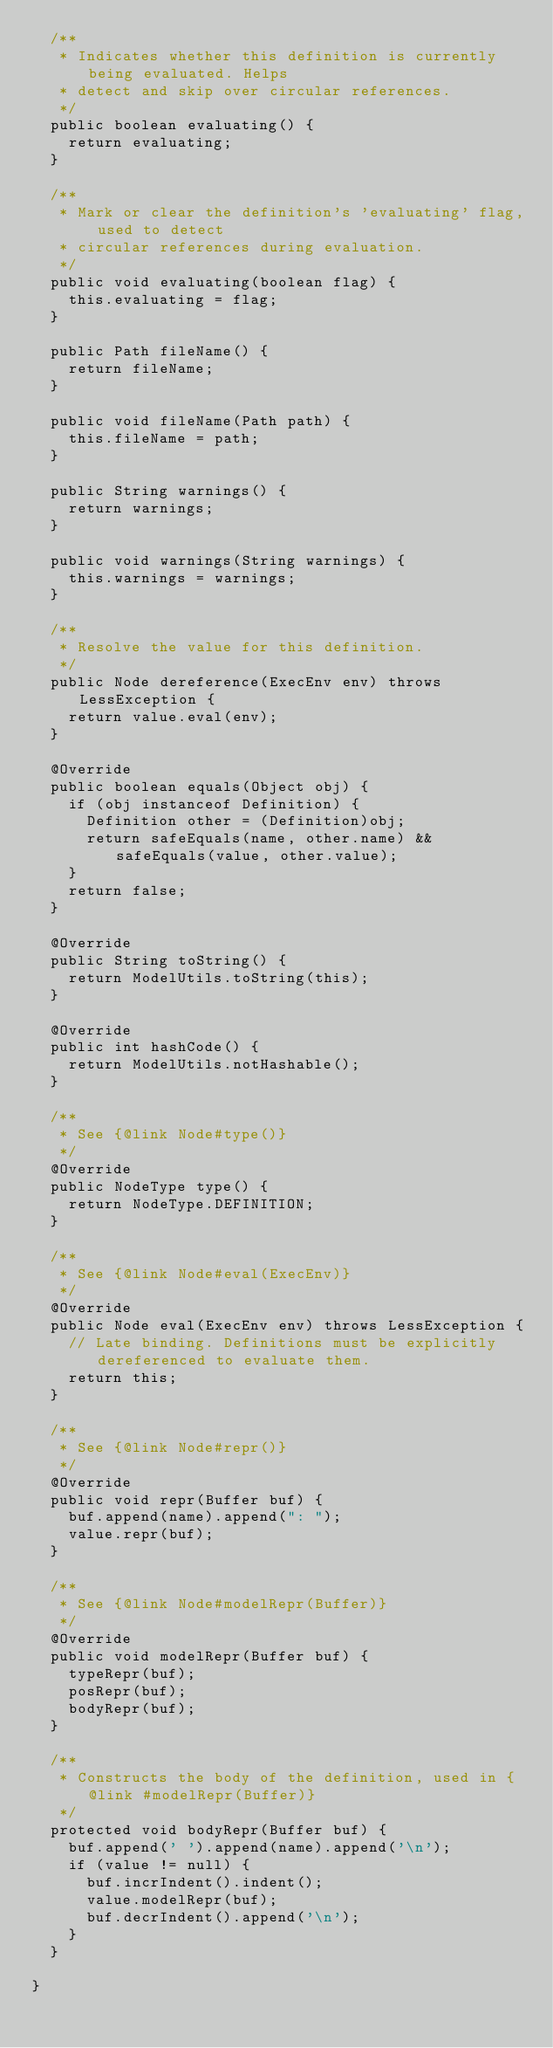<code> <loc_0><loc_0><loc_500><loc_500><_Java_>  /**
   * Indicates whether this definition is currently being evaluated. Helps
   * detect and skip over circular references.
   */
  public boolean evaluating() {
    return evaluating;
  }

  /**
   * Mark or clear the definition's 'evaluating' flag, used to detect
   * circular references during evaluation.
   */
  public void evaluating(boolean flag) {
    this.evaluating = flag;
  }

  public Path fileName() {
    return fileName;
  }

  public void fileName(Path path) {
    this.fileName = path;
  }

  public String warnings() {
    return warnings;
  }

  public void warnings(String warnings) {
    this.warnings = warnings;
  }

  /**
   * Resolve the value for this definition.
   */
  public Node dereference(ExecEnv env) throws LessException {
    return value.eval(env);
  }

  @Override
  public boolean equals(Object obj) {
    if (obj instanceof Definition) {
      Definition other = (Definition)obj;
      return safeEquals(name, other.name) && safeEquals(value, other.value);
    }
    return false;
  }

  @Override
  public String toString() {
    return ModelUtils.toString(this);
  }

  @Override
  public int hashCode() {
    return ModelUtils.notHashable();
  }

  /**
   * See {@link Node#type()}
   */
  @Override
  public NodeType type() {
    return NodeType.DEFINITION;
  }

  /**
   * See {@link Node#eval(ExecEnv)}
   */
  @Override
  public Node eval(ExecEnv env) throws LessException {
    // Late binding. Definitions must be explicitly dereferenced to evaluate them.
    return this;
  }

  /**
   * See {@link Node#repr()}
   */
  @Override
  public void repr(Buffer buf) {
    buf.append(name).append(": ");
    value.repr(buf);
  }

  /**
   * See {@link Node#modelRepr(Buffer)}
   */
  @Override
  public void modelRepr(Buffer buf) {
    typeRepr(buf);
    posRepr(buf);
    bodyRepr(buf);
  }

  /**
   * Constructs the body of the definition, used in {@link #modelRepr(Buffer)}
   */
  protected void bodyRepr(Buffer buf) {
    buf.append(' ').append(name).append('\n');
    if (value != null) {
      buf.incrIndent().indent();
      value.modelRepr(buf);
      buf.decrIndent().append('\n');
    }
  }

}
</code> 